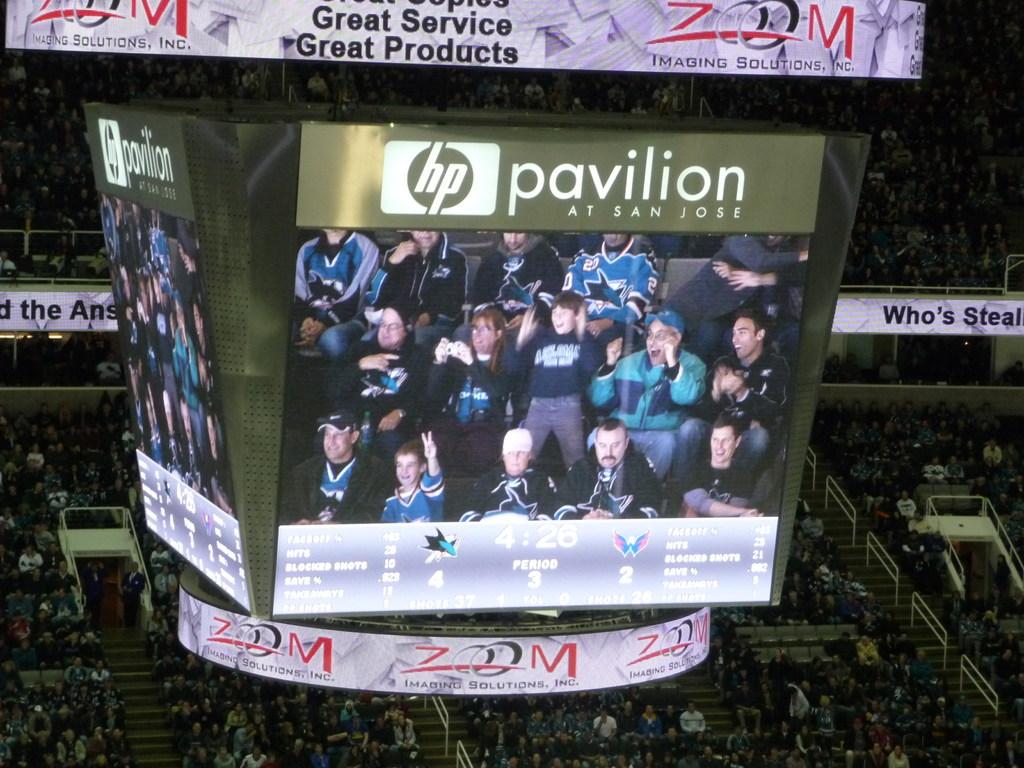What company logo is shown above the crowd on the display?
Your answer should be very brief. Hp. 